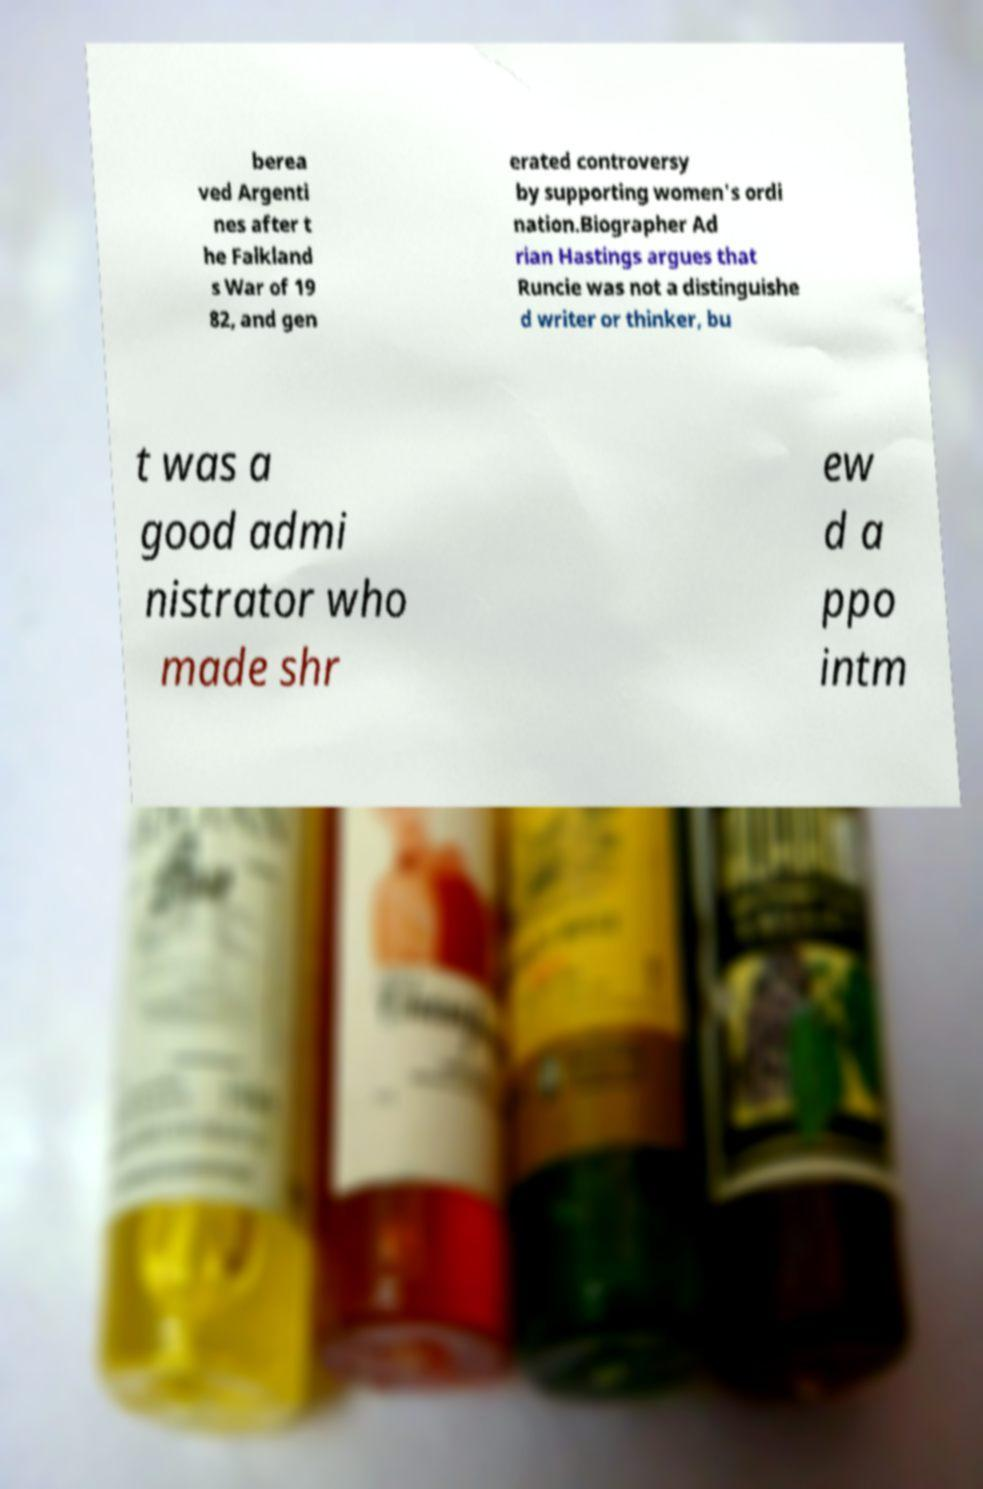Could you extract and type out the text from this image? berea ved Argenti nes after t he Falkland s War of 19 82, and gen erated controversy by supporting women's ordi nation.Biographer Ad rian Hastings argues that Runcie was not a distinguishe d writer or thinker, bu t was a good admi nistrator who made shr ew d a ppo intm 